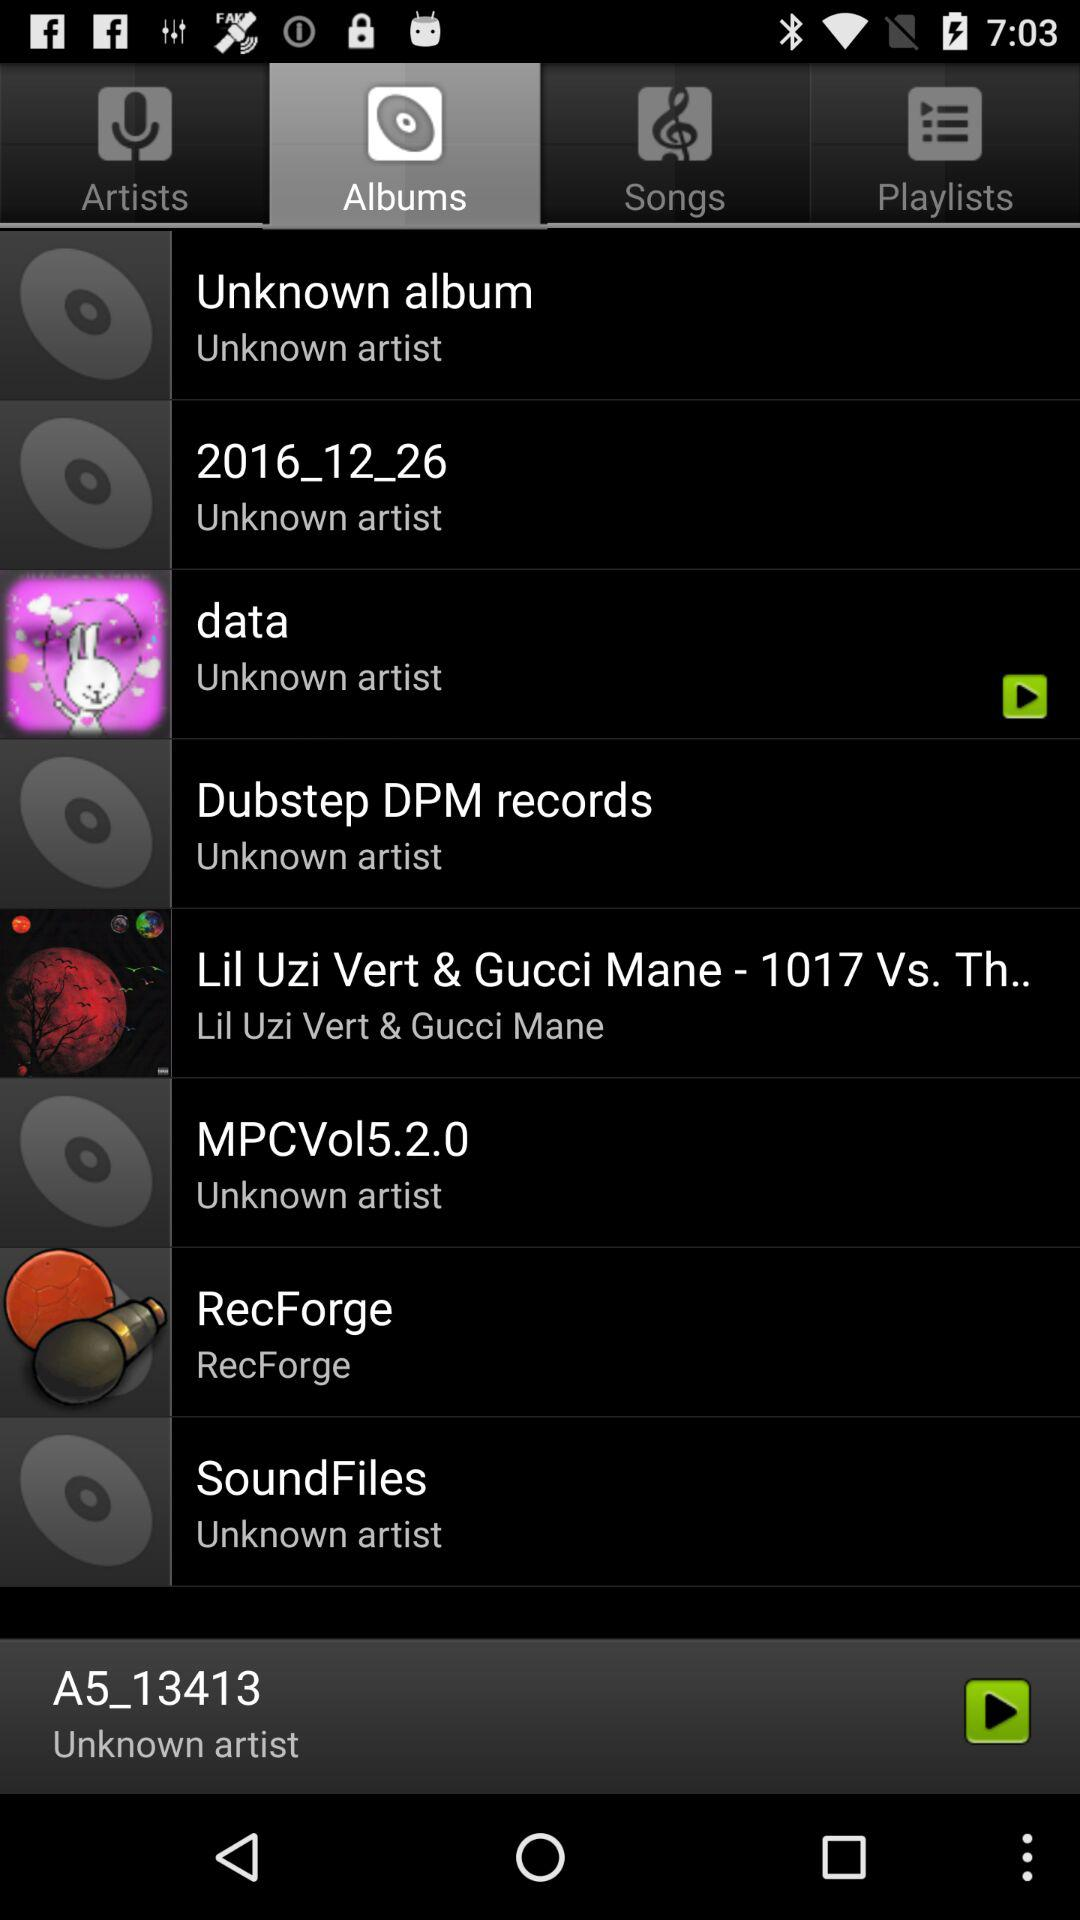Which tab is selected? The selected tab is "Albums". 